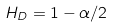<formula> <loc_0><loc_0><loc_500><loc_500>H _ { D } = 1 - \alpha / 2</formula> 